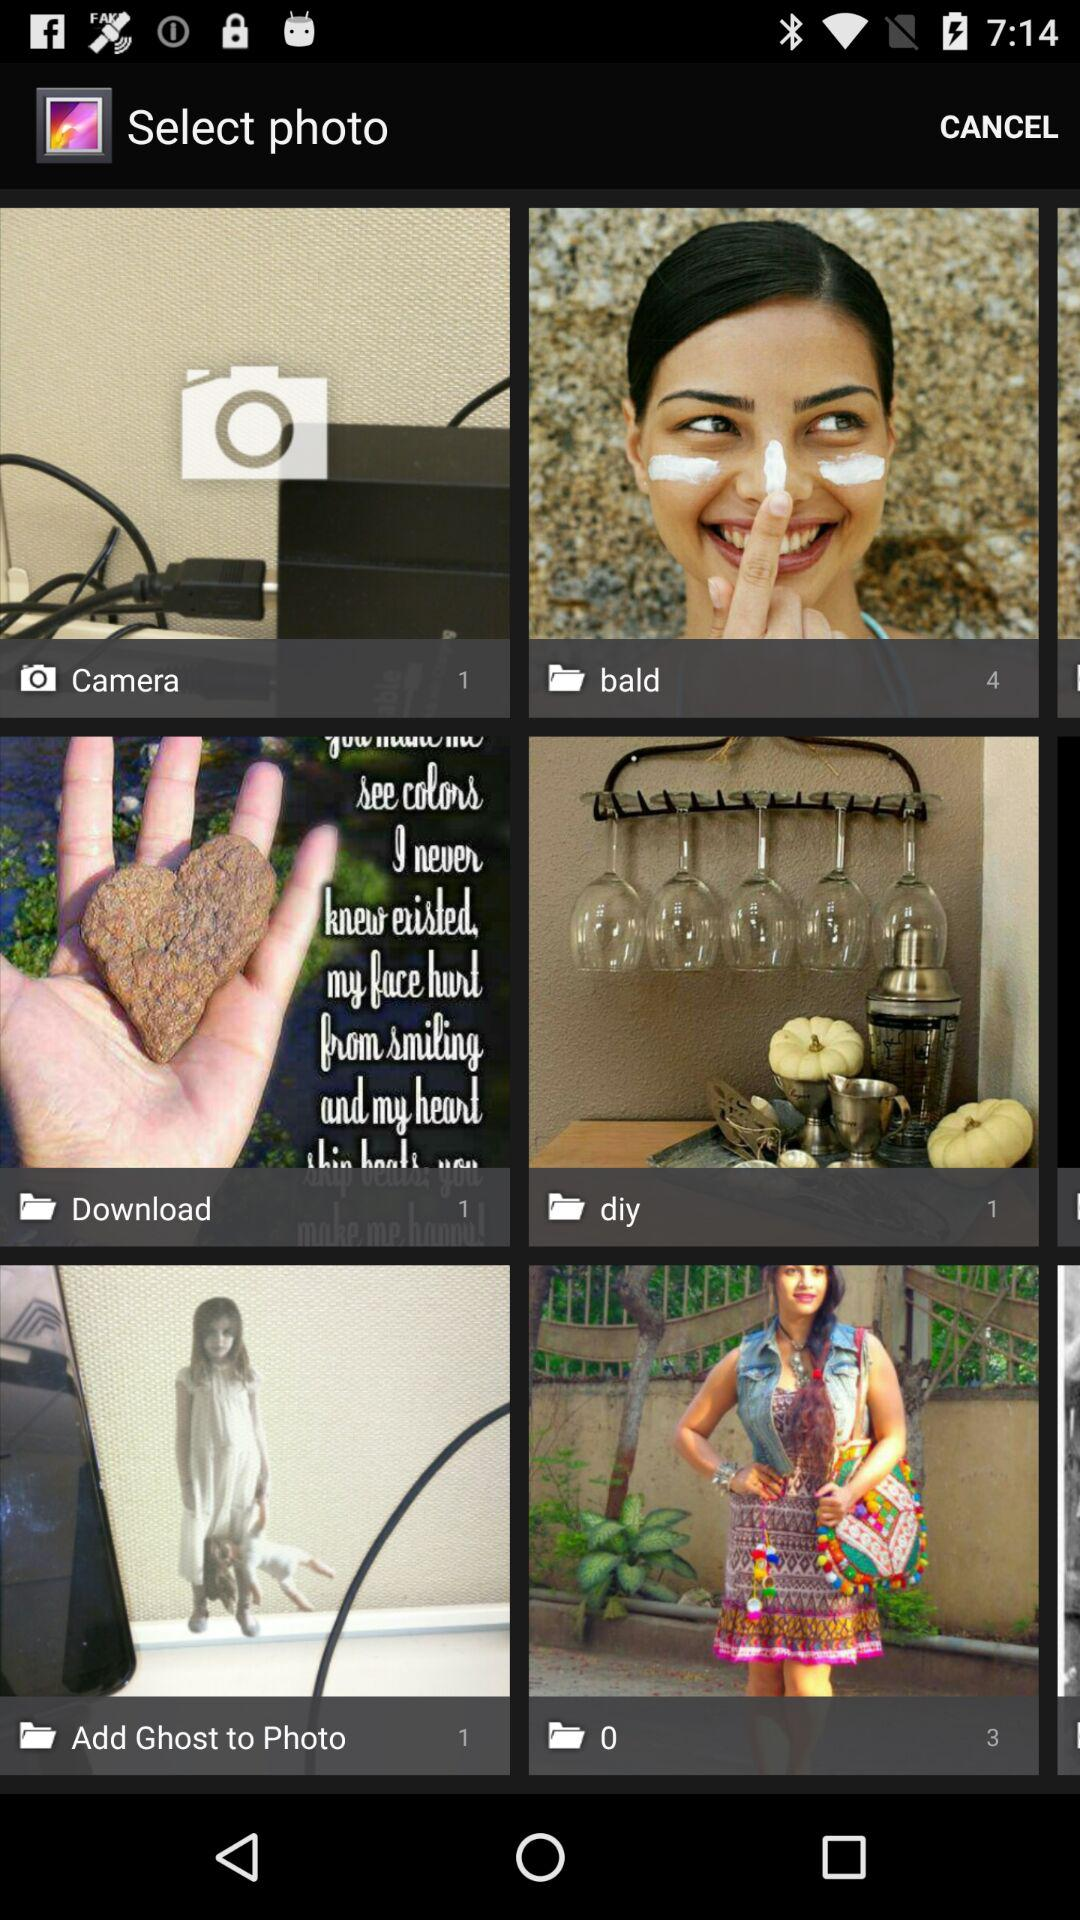How many photos are present in the "diy" folder? There is 1 photo in the "diy" folder. 